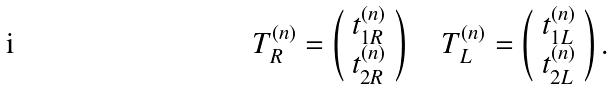<formula> <loc_0><loc_0><loc_500><loc_500>T _ { R } ^ { ( n ) } = \left ( \begin{array} { c } t _ { 1 R } ^ { ( n ) } \\ t _ { 2 R } ^ { ( n ) } \end{array} \right ) \quad T _ { L } ^ { ( n ) } = \left ( \begin{array} { c } t _ { 1 L } ^ { ( n ) } \\ t _ { 2 L } ^ { ( n ) } \end{array} \right ) .</formula> 